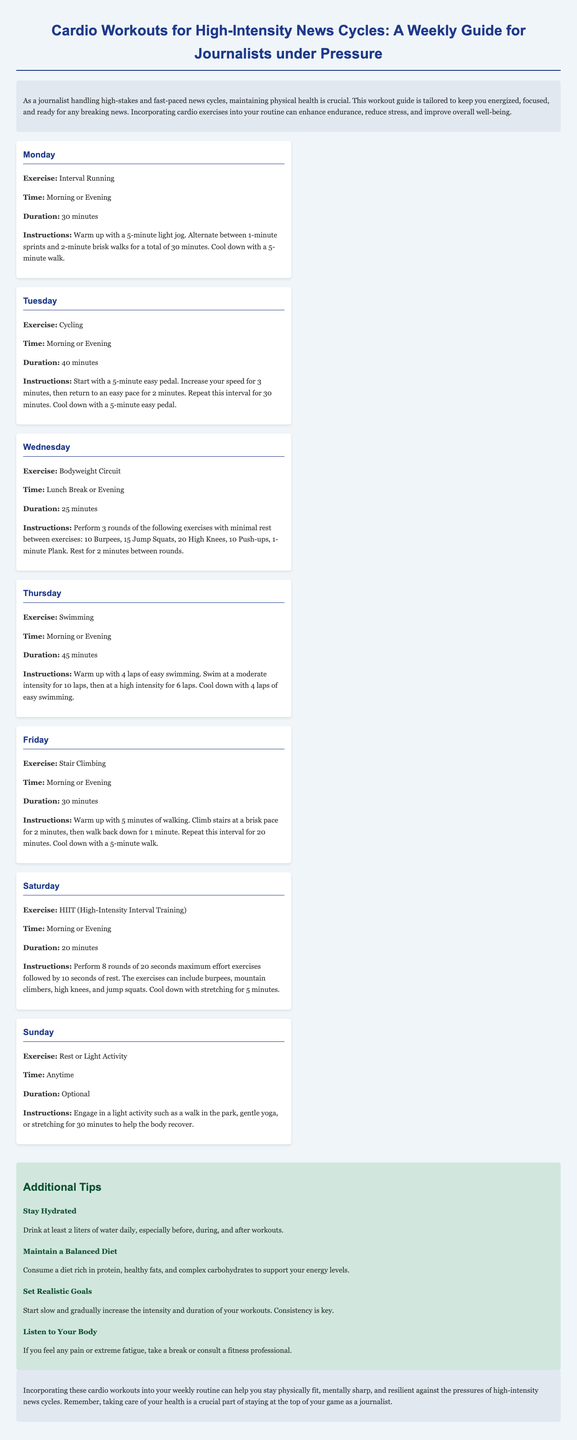what is the primary focus of the document? The document provides a workout guide specifically for journalists during high-intensity news cycles.
Answer: cardio workouts how long is the interval running workout? The document specifies the duration for the interval running workout.
Answer: 30 minutes which exercise involves swimming? This question targets a specific activity listed in the workout plan.
Answer: Swimming how many exercises are included in the bodyweight circuit? The document mentions the specific number of exercises to be performed in the circuit.
Answer: 5 exercises what is recommended for Sunday workouts? This question asks for the specific suggestion listed for Sunday in the workout plan.
Answer: Rest or Light Activity what is the recommended hydration amount? The document mentions how much water should be consumed daily.
Answer: 2 liters what type of training is suggested for Saturday? This question inquires about the specific workout type listed for Saturday.
Answer: HIIT (High-Intensity Interval Training) how many laps are suggested for the swimming warm-up? The specific number of warm-up laps for swimming is stated in the document.
Answer: 4 laps what should you do if experiencing pain during workouts? This question focuses on advice given in the document regarding health during exercise.
Answer: take a break or consult a fitness professional 